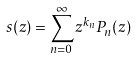<formula> <loc_0><loc_0><loc_500><loc_500>s ( z ) = \sum _ { n = 0 } ^ { \infty } z ^ { k _ { n } } P _ { n } ( z )</formula> 